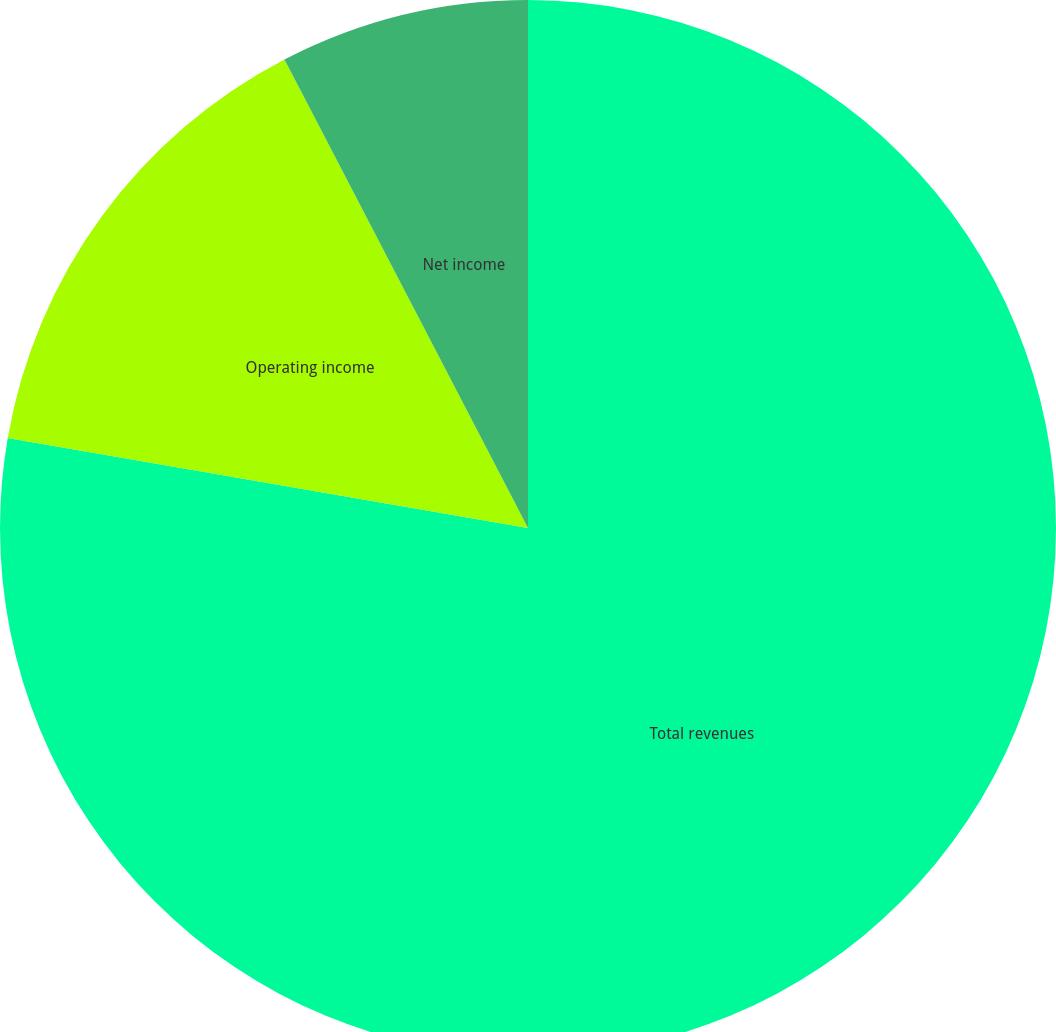Convert chart. <chart><loc_0><loc_0><loc_500><loc_500><pie_chart><fcel>Total revenues<fcel>Operating income<fcel>Net income<nl><fcel>77.73%<fcel>14.64%<fcel>7.63%<nl></chart> 